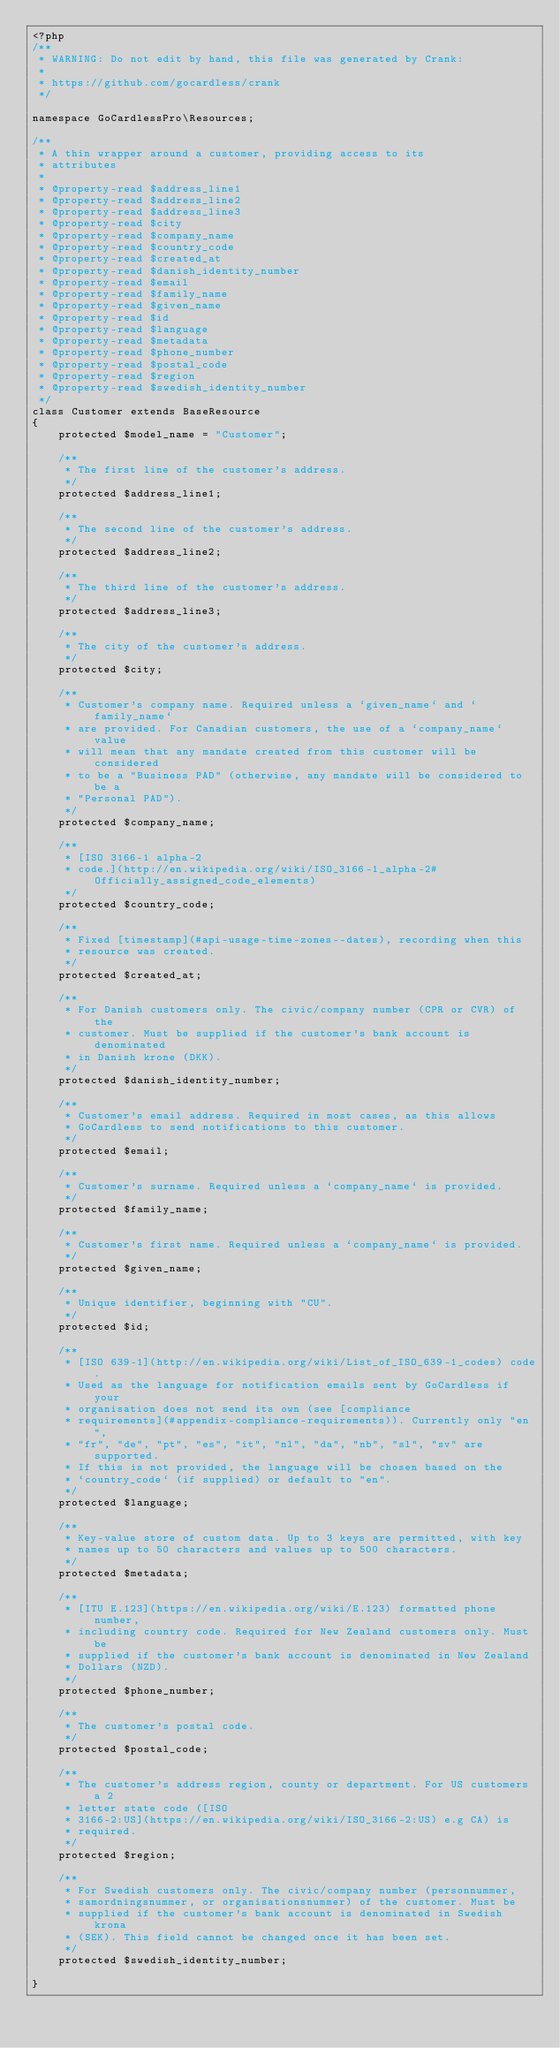Convert code to text. <code><loc_0><loc_0><loc_500><loc_500><_PHP_><?php
/**
 * WARNING: Do not edit by hand, this file was generated by Crank:
 *
 * https://github.com/gocardless/crank
 */

namespace GoCardlessPro\Resources;

/**
 * A thin wrapper around a customer, providing access to its
 * attributes
 *
 * @property-read $address_line1
 * @property-read $address_line2
 * @property-read $address_line3
 * @property-read $city
 * @property-read $company_name
 * @property-read $country_code
 * @property-read $created_at
 * @property-read $danish_identity_number
 * @property-read $email
 * @property-read $family_name
 * @property-read $given_name
 * @property-read $id
 * @property-read $language
 * @property-read $metadata
 * @property-read $phone_number
 * @property-read $postal_code
 * @property-read $region
 * @property-read $swedish_identity_number
 */
class Customer extends BaseResource
{
    protected $model_name = "Customer";

    /**
     * The first line of the customer's address.
     */
    protected $address_line1;

    /**
     * The second line of the customer's address.
     */
    protected $address_line2;

    /**
     * The third line of the customer's address.
     */
    protected $address_line3;

    /**
     * The city of the customer's address.
     */
    protected $city;

    /**
     * Customer's company name. Required unless a `given_name` and `family_name`
     * are provided. For Canadian customers, the use of a `company_name` value
     * will mean that any mandate created from this customer will be considered
     * to be a "Business PAD" (otherwise, any mandate will be considered to be a
     * "Personal PAD").
     */
    protected $company_name;

    /**
     * [ISO 3166-1 alpha-2
     * code.](http://en.wikipedia.org/wiki/ISO_3166-1_alpha-2#Officially_assigned_code_elements)
     */
    protected $country_code;

    /**
     * Fixed [timestamp](#api-usage-time-zones--dates), recording when this
     * resource was created.
     */
    protected $created_at;

    /**
     * For Danish customers only. The civic/company number (CPR or CVR) of the
     * customer. Must be supplied if the customer's bank account is denominated
     * in Danish krone (DKK).
     */
    protected $danish_identity_number;

    /**
     * Customer's email address. Required in most cases, as this allows
     * GoCardless to send notifications to this customer.
     */
    protected $email;

    /**
     * Customer's surname. Required unless a `company_name` is provided.
     */
    protected $family_name;

    /**
     * Customer's first name. Required unless a `company_name` is provided.
     */
    protected $given_name;

    /**
     * Unique identifier, beginning with "CU".
     */
    protected $id;

    /**
     * [ISO 639-1](http://en.wikipedia.org/wiki/List_of_ISO_639-1_codes) code.
     * Used as the language for notification emails sent by GoCardless if your
     * organisation does not send its own (see [compliance
     * requirements](#appendix-compliance-requirements)). Currently only "en",
     * "fr", "de", "pt", "es", "it", "nl", "da", "nb", "sl", "sv" are supported.
     * If this is not provided, the language will be chosen based on the
     * `country_code` (if supplied) or default to "en".
     */
    protected $language;

    /**
     * Key-value store of custom data. Up to 3 keys are permitted, with key
     * names up to 50 characters and values up to 500 characters.
     */
    protected $metadata;

    /**
     * [ITU E.123](https://en.wikipedia.org/wiki/E.123) formatted phone number,
     * including country code. Required for New Zealand customers only. Must be
     * supplied if the customer's bank account is denominated in New Zealand
     * Dollars (NZD).
     */
    protected $phone_number;

    /**
     * The customer's postal code.
     */
    protected $postal_code;

    /**
     * The customer's address region, county or department. For US customers a 2
     * letter state code ([ISO
     * 3166-2:US](https://en.wikipedia.org/wiki/ISO_3166-2:US) e.g CA) is
     * required.
     */
    protected $region;

    /**
     * For Swedish customers only. The civic/company number (personnummer,
     * samordningsnummer, or organisationsnummer) of the customer. Must be
     * supplied if the customer's bank account is denominated in Swedish krona
     * (SEK). This field cannot be changed once it has been set.
     */
    protected $swedish_identity_number;

}
</code> 